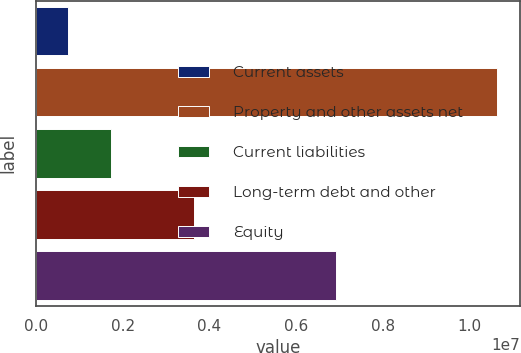<chart> <loc_0><loc_0><loc_500><loc_500><bar_chart><fcel>Current assets<fcel>Property and other assets net<fcel>Current liabilities<fcel>Long-term debt and other<fcel>Equity<nl><fcel>731381<fcel>1.06347e+07<fcel>1.72171e+06<fcel>3.64576e+06<fcel>6.92068e+06<nl></chart> 